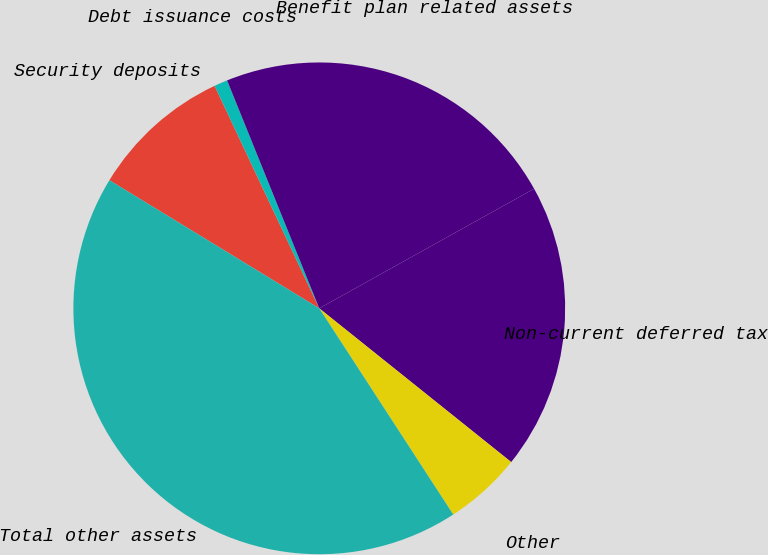<chart> <loc_0><loc_0><loc_500><loc_500><pie_chart><fcel>Security deposits<fcel>Debt issuance costs<fcel>Benefit plan related assets<fcel>Non-current deferred tax<fcel>Other<fcel>Total other assets<nl><fcel>9.28%<fcel>0.88%<fcel>23.03%<fcel>18.83%<fcel>5.08%<fcel>42.89%<nl></chart> 